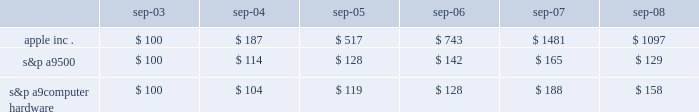Table of contents company stock performance the following graph shows a five-year comparison of cumulative total shareholder return , calculated on a dividend reinvested basis , for the company , the s&p 500 composite index ( the 201cs&p 500 201d ) and the s&p computers ( hardware ) index ( the 201cindustry index 201d ) .
The graph assumes $ 100 was invested in each of the company 2019s common stock , the s&p 500 , and the industry index on september 30 , 2003 .
Data points on the graph are annual .
Note that historic stock price performance is not necessarily indicative of future stock price performance .
Copyright a9 2008 , standard & poor 2019s , a division of the mcgraw-hill companies , inc .
All rights reserved. .
S&p a9 500 $ 100 $ 114 $ 128 $ 142 $ 165 $ 129 s&p a9 computer hardware $ 100 $ 104 $ 119 $ 128 $ 188 $ 158 .
What was the change in cumulative total return for the s&p a9500 between 2003 and 2004? 
Computations: (100 - 114)
Answer: -14.0. 